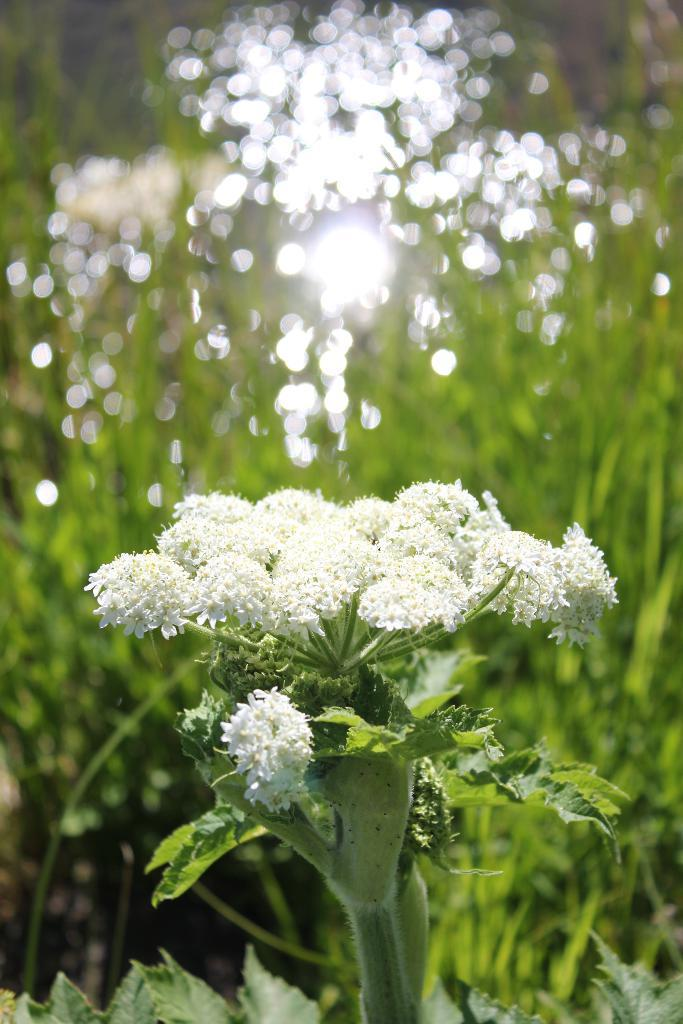What is present in the image? There is a plant in the image. What specific feature of the plant can be observed? The plant contains flowers. Can you describe the background of the image? The background of the image is blurred. How many girls are running with cattle in the image? There are no girls or cattle present in the image; it features a plant with flowers and a blurred background. 